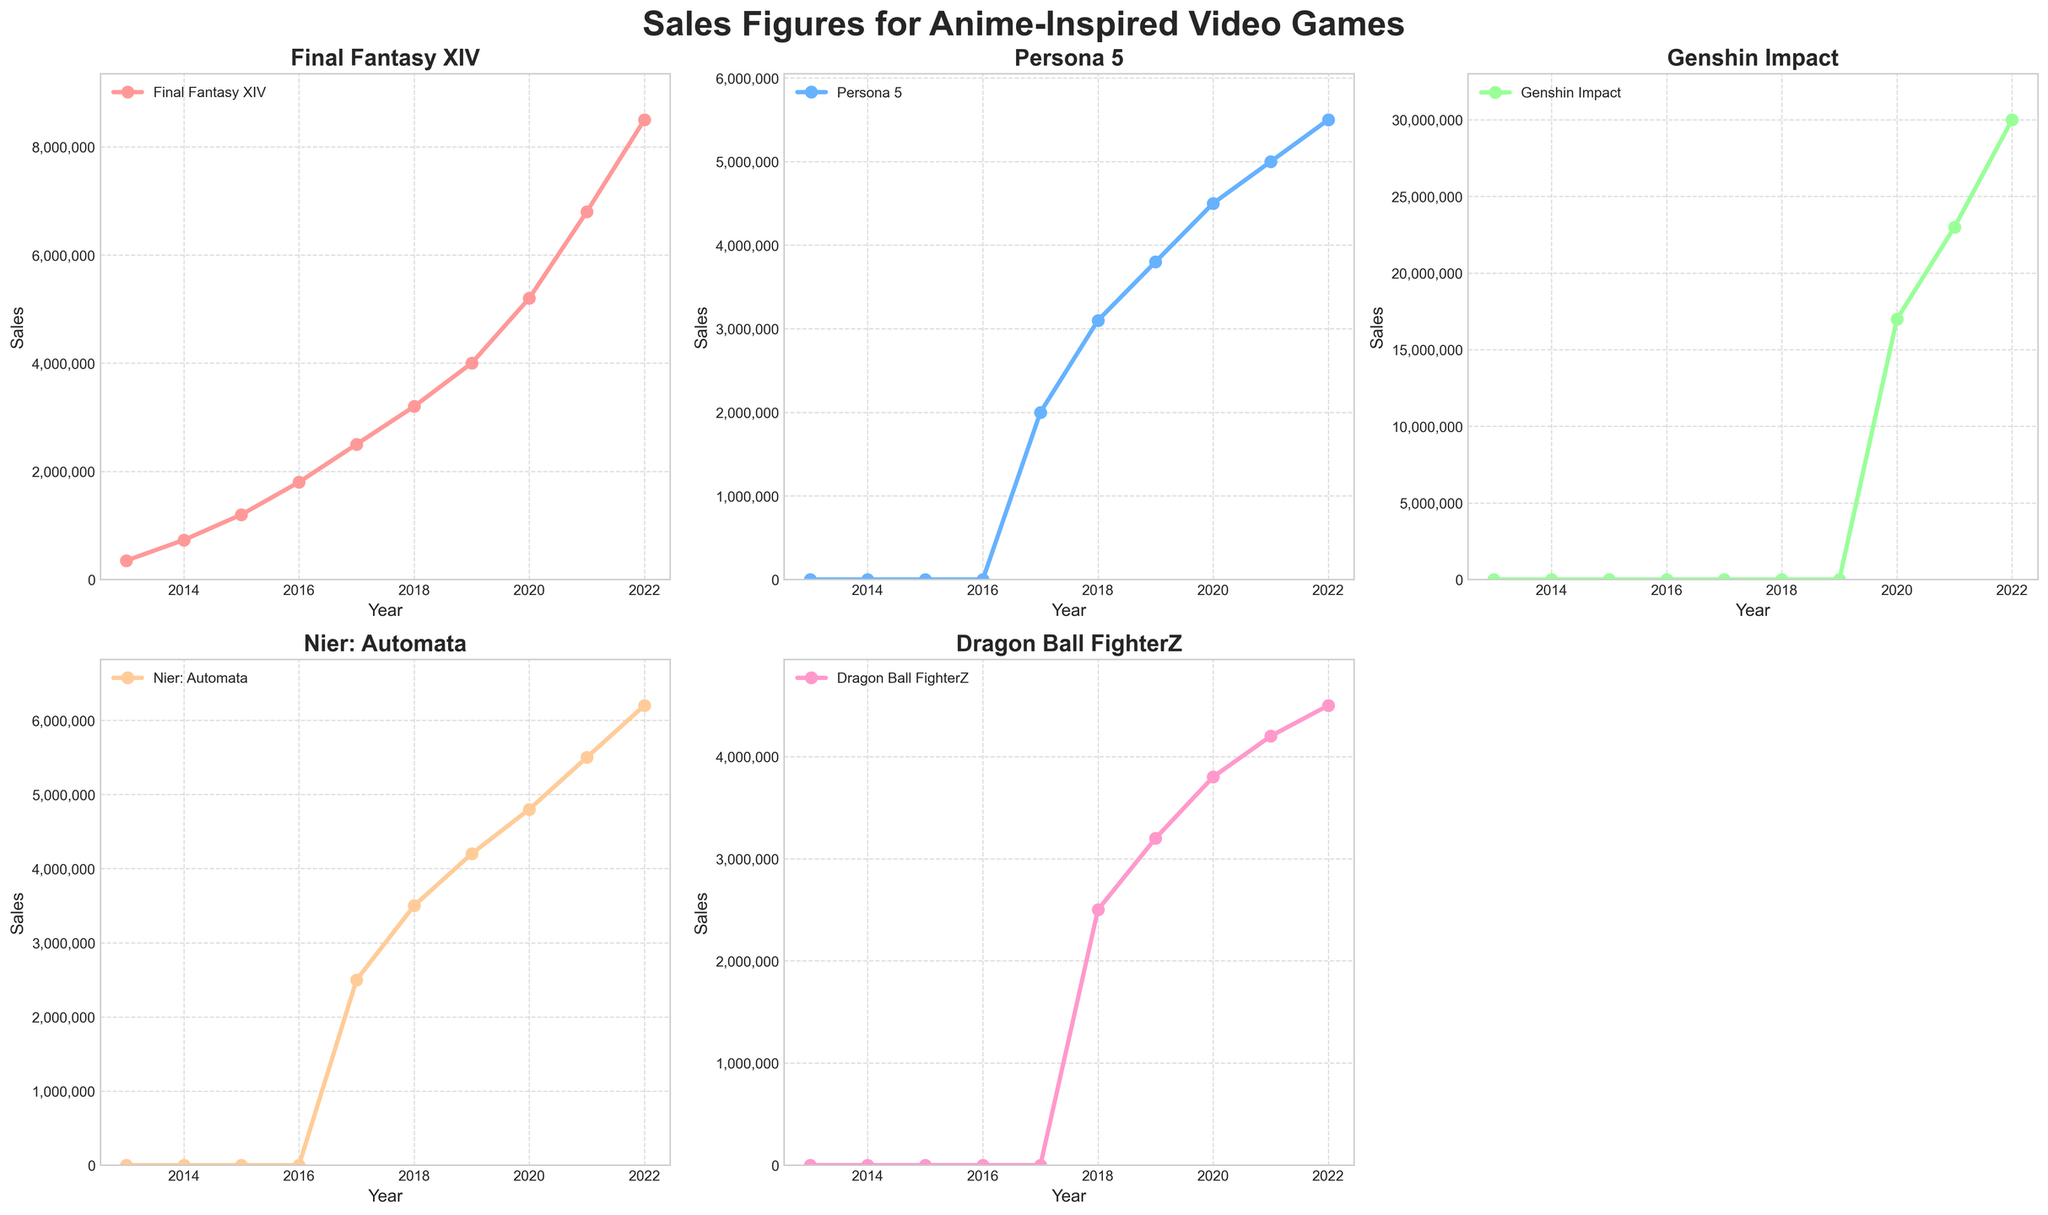What's the sales title for the subplot in the top-left? The subplot in the top-left is the first subplot, and its title corresponds with the first game listed in the code and dataset, which is "Final Fantasy XIV".
Answer: Final Fantasy XIV How does the sales growth of Persona 5 from 2017 to 2022 compare with the sales growth of Final Fantasy XIV over the same period? To compare the sales growth, we look at the sales for each game in 2017 and 2022. For Persona 5, the sales in 2017 were 2,000,000 and in 2022 they were 5,500,000. The growth is 5,500,000 - 2,000,000 = 3,500,000. For Final Fantasy XIV, the sales in 2017 were 2,500,000 and in 2022 they were 8,500,000. The growth is 8,500,000 - 2,500,000 = 6,000,000.
Answer: Final Fantasy XIV: 6,000,000, Persona 5: 3,500,000 Which game had zero sales before the year 2020? By looking at the sales values for each game, we can see that "Genshin Impact" had zeros in 2013, 2014, 2015, 2016, 2017, 2018, and 2019.
Answer: Genshin Impact What is the trend in Dragon Ball FighterZ sales between 2018 and 2022? We examine the yearly sales values for Dragon Ball FighterZ. From 2018 to 2022, the sales are: 2500000, 3200000, 3800000, 4200000, 4500000. This shows a consistent upward trend.
Answer: Upward trend Between 2017 and 2022, which year did Nier: Automata see the highest jump in sales? We check the difference in sales for each year within this range. The sales were: 2017: 2,500,000; 2018: 3,500,000; 2019: 4,200,000; 2020: 4,800,000; 2021: 5,500,000; 2022: 6,200,000. The highest jump happened between 2017 and 2018. The jump is 3,500,000 - 2,500,000 = 1,000,000.
Answer: Between 2017 and 2018 What is the overall increase in sales for Final Fantasy XIV from 2013 to 2022? To find the overall increase for Final Fantasy XIV, subtract the sales in 2013 from the sales in 2022: 8,500,000 - 350,000 = 8,150,000.
Answer: 8,150,000 Which game has the highest sales value plotted and in what year? By evaluating all plotted sales values, we see that "Genshin Impact" in 2022 has the highest sales value of 30,000,000.
Answer: Genshin Impact, 2022 